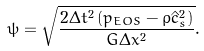Convert formula to latex. <formula><loc_0><loc_0><loc_500><loc_500>\psi = \sqrt { \frac { { 2 \Delta { t ^ { 2 } } \left ( { { p _ { E O S } } - \rho \hat { c } _ { s } ^ { 2 } } \right ) } } { { G \Delta { x ^ { 2 } } } } } .</formula> 